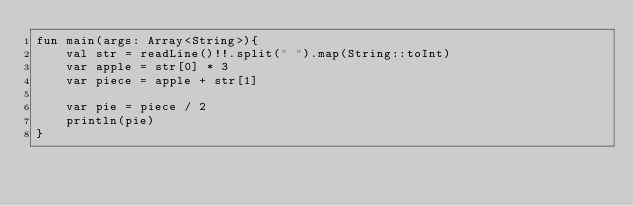<code> <loc_0><loc_0><loc_500><loc_500><_Kotlin_>fun main(args: Array<String>){
    val str = readLine()!!.split(" ").map(String::toInt)
    var apple = str[0] * 3
    var piece = apple + str[1]

    var pie = piece / 2
    println(pie)
}
</code> 